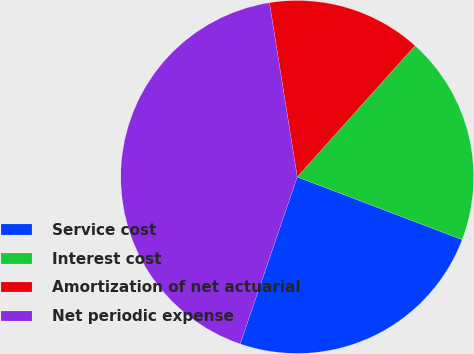Convert chart to OTSL. <chart><loc_0><loc_0><loc_500><loc_500><pie_chart><fcel>Service cost<fcel>Interest cost<fcel>Amortization of net actuarial<fcel>Net periodic expense<nl><fcel>24.46%<fcel>19.14%<fcel>14.16%<fcel>42.24%<nl></chart> 